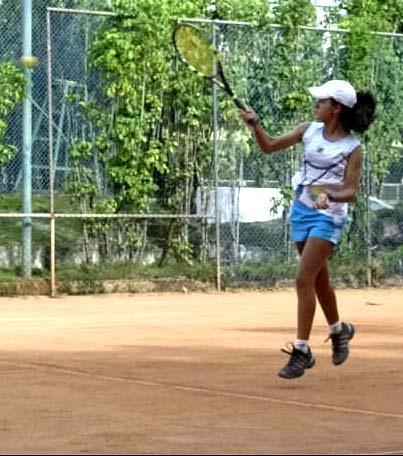How many players are visible?
Give a very brief answer. 1. How many people are in the photo?
Give a very brief answer. 1. 